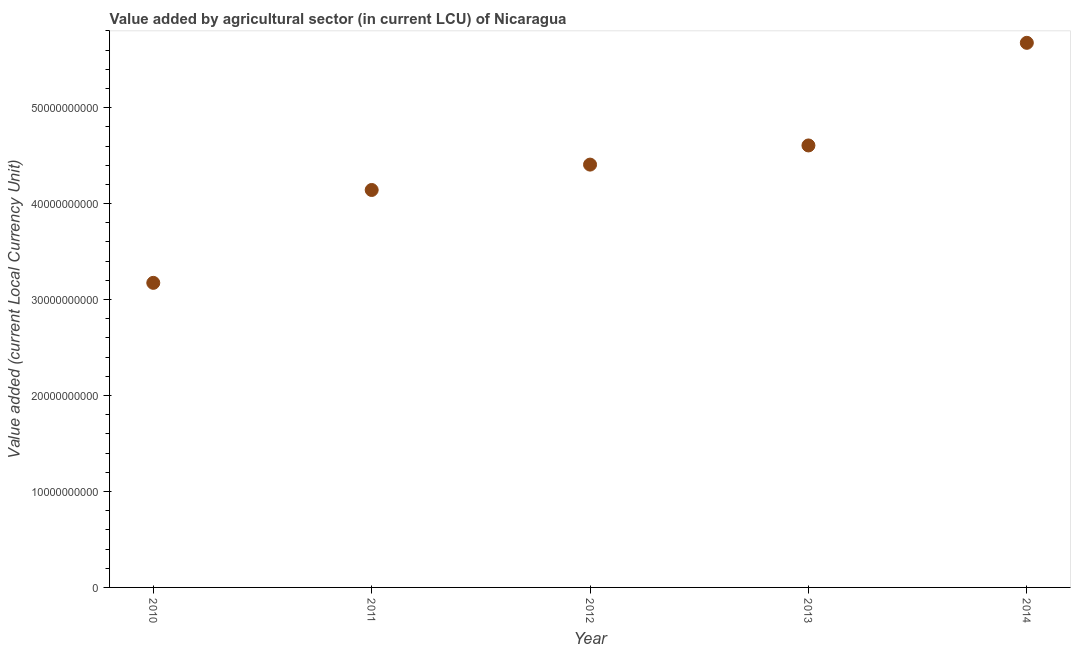What is the value added by agriculture sector in 2010?
Make the answer very short. 3.17e+1. Across all years, what is the maximum value added by agriculture sector?
Give a very brief answer. 5.68e+1. Across all years, what is the minimum value added by agriculture sector?
Ensure brevity in your answer.  3.17e+1. In which year was the value added by agriculture sector maximum?
Your response must be concise. 2014. In which year was the value added by agriculture sector minimum?
Offer a very short reply. 2010. What is the sum of the value added by agriculture sector?
Ensure brevity in your answer.  2.20e+11. What is the difference between the value added by agriculture sector in 2010 and 2012?
Your answer should be compact. -1.23e+1. What is the average value added by agriculture sector per year?
Provide a short and direct response. 4.40e+1. What is the median value added by agriculture sector?
Keep it short and to the point. 4.41e+1. What is the ratio of the value added by agriculture sector in 2012 to that in 2013?
Offer a terse response. 0.96. What is the difference between the highest and the second highest value added by agriculture sector?
Provide a succinct answer. 1.07e+1. What is the difference between the highest and the lowest value added by agriculture sector?
Offer a very short reply. 2.50e+1. Does the value added by agriculture sector monotonically increase over the years?
Your answer should be compact. Yes. How many dotlines are there?
Your answer should be compact. 1. Does the graph contain grids?
Provide a short and direct response. No. What is the title of the graph?
Your answer should be very brief. Value added by agricultural sector (in current LCU) of Nicaragua. What is the label or title of the X-axis?
Give a very brief answer. Year. What is the label or title of the Y-axis?
Give a very brief answer. Value added (current Local Currency Unit). What is the Value added (current Local Currency Unit) in 2010?
Offer a terse response. 3.17e+1. What is the Value added (current Local Currency Unit) in 2011?
Provide a succinct answer. 4.14e+1. What is the Value added (current Local Currency Unit) in 2012?
Provide a succinct answer. 4.41e+1. What is the Value added (current Local Currency Unit) in 2013?
Provide a short and direct response. 4.61e+1. What is the Value added (current Local Currency Unit) in 2014?
Provide a succinct answer. 5.68e+1. What is the difference between the Value added (current Local Currency Unit) in 2010 and 2011?
Ensure brevity in your answer.  -9.68e+09. What is the difference between the Value added (current Local Currency Unit) in 2010 and 2012?
Make the answer very short. -1.23e+1. What is the difference between the Value added (current Local Currency Unit) in 2010 and 2013?
Make the answer very short. -1.43e+1. What is the difference between the Value added (current Local Currency Unit) in 2010 and 2014?
Offer a terse response. -2.50e+1. What is the difference between the Value added (current Local Currency Unit) in 2011 and 2012?
Ensure brevity in your answer.  -2.64e+09. What is the difference between the Value added (current Local Currency Unit) in 2011 and 2013?
Offer a very short reply. -4.64e+09. What is the difference between the Value added (current Local Currency Unit) in 2011 and 2014?
Provide a short and direct response. -1.53e+1. What is the difference between the Value added (current Local Currency Unit) in 2012 and 2013?
Ensure brevity in your answer.  -2.00e+09. What is the difference between the Value added (current Local Currency Unit) in 2012 and 2014?
Your answer should be compact. -1.27e+1. What is the difference between the Value added (current Local Currency Unit) in 2013 and 2014?
Keep it short and to the point. -1.07e+1. What is the ratio of the Value added (current Local Currency Unit) in 2010 to that in 2011?
Offer a very short reply. 0.77. What is the ratio of the Value added (current Local Currency Unit) in 2010 to that in 2012?
Your answer should be very brief. 0.72. What is the ratio of the Value added (current Local Currency Unit) in 2010 to that in 2013?
Provide a short and direct response. 0.69. What is the ratio of the Value added (current Local Currency Unit) in 2010 to that in 2014?
Your answer should be very brief. 0.56. What is the ratio of the Value added (current Local Currency Unit) in 2011 to that in 2013?
Offer a very short reply. 0.9. What is the ratio of the Value added (current Local Currency Unit) in 2011 to that in 2014?
Make the answer very short. 0.73. What is the ratio of the Value added (current Local Currency Unit) in 2012 to that in 2014?
Offer a very short reply. 0.78. What is the ratio of the Value added (current Local Currency Unit) in 2013 to that in 2014?
Keep it short and to the point. 0.81. 